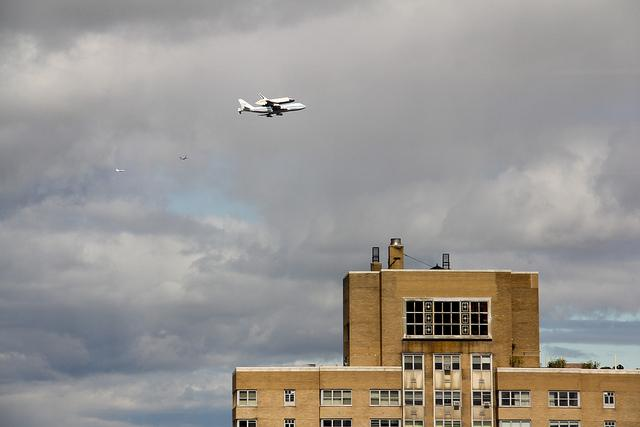What is the plane flying over?

Choices:
A) mountain
B) building
C) lake
D) forest building 